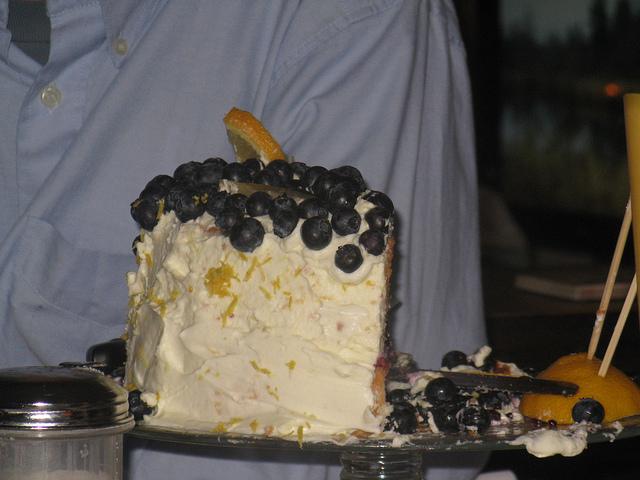What is on the top of this cake?
Answer briefly. Blueberries. What is on top of the cake?
Write a very short answer. Blueberries. Does the cake look good?
Keep it brief. Yes. How many candy apples are there?
Keep it brief. 0. This is being served for breakfast?
Write a very short answer. No. What are the popsicle sticks used for?
Concise answer only. Decoration. What is the cake covered with?
Be succinct. Blueberries. Have they eaten the dessert?
Write a very short answer. Yes. What flavor is the cake?
Quick response, please. Blueberry. Is there a candle on the cake?
Give a very brief answer. No. Are there sprinkles on top of the cake?
Be succinct. No. Is there more than one fruit  pictured?
Answer briefly. Yes. What fruit is atop the cake?
Short answer required. Orange. 